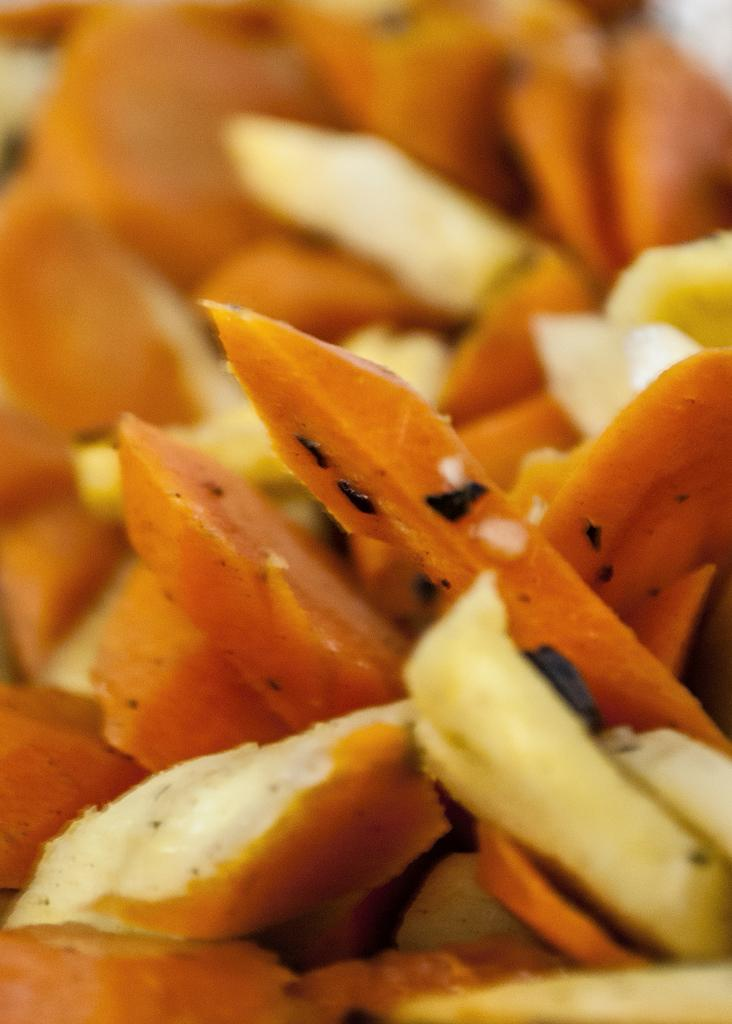What type of food can be seen in the image? There are cut pieces of vegetables in the image. How are the vegetables presented in the image? The vegetables are cut into pieces. What type of pizzas does the governor prefer in the image? There is no mention of pizzas or a governor in the image, so we cannot answer this question. 